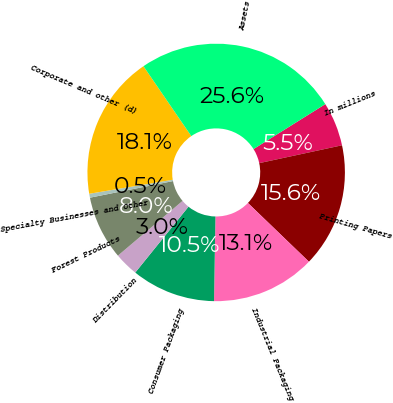Convert chart. <chart><loc_0><loc_0><loc_500><loc_500><pie_chart><fcel>In millions<fcel>Printing Papers<fcel>Industrial Packaging<fcel>Consumer Packaging<fcel>Distribution<fcel>Forest Products<fcel>Specialty Businesses and Other<fcel>Corporate and other (d)<fcel>Assets<nl><fcel>5.52%<fcel>15.58%<fcel>13.07%<fcel>10.55%<fcel>3.0%<fcel>8.04%<fcel>0.49%<fcel>18.1%<fcel>25.65%<nl></chart> 